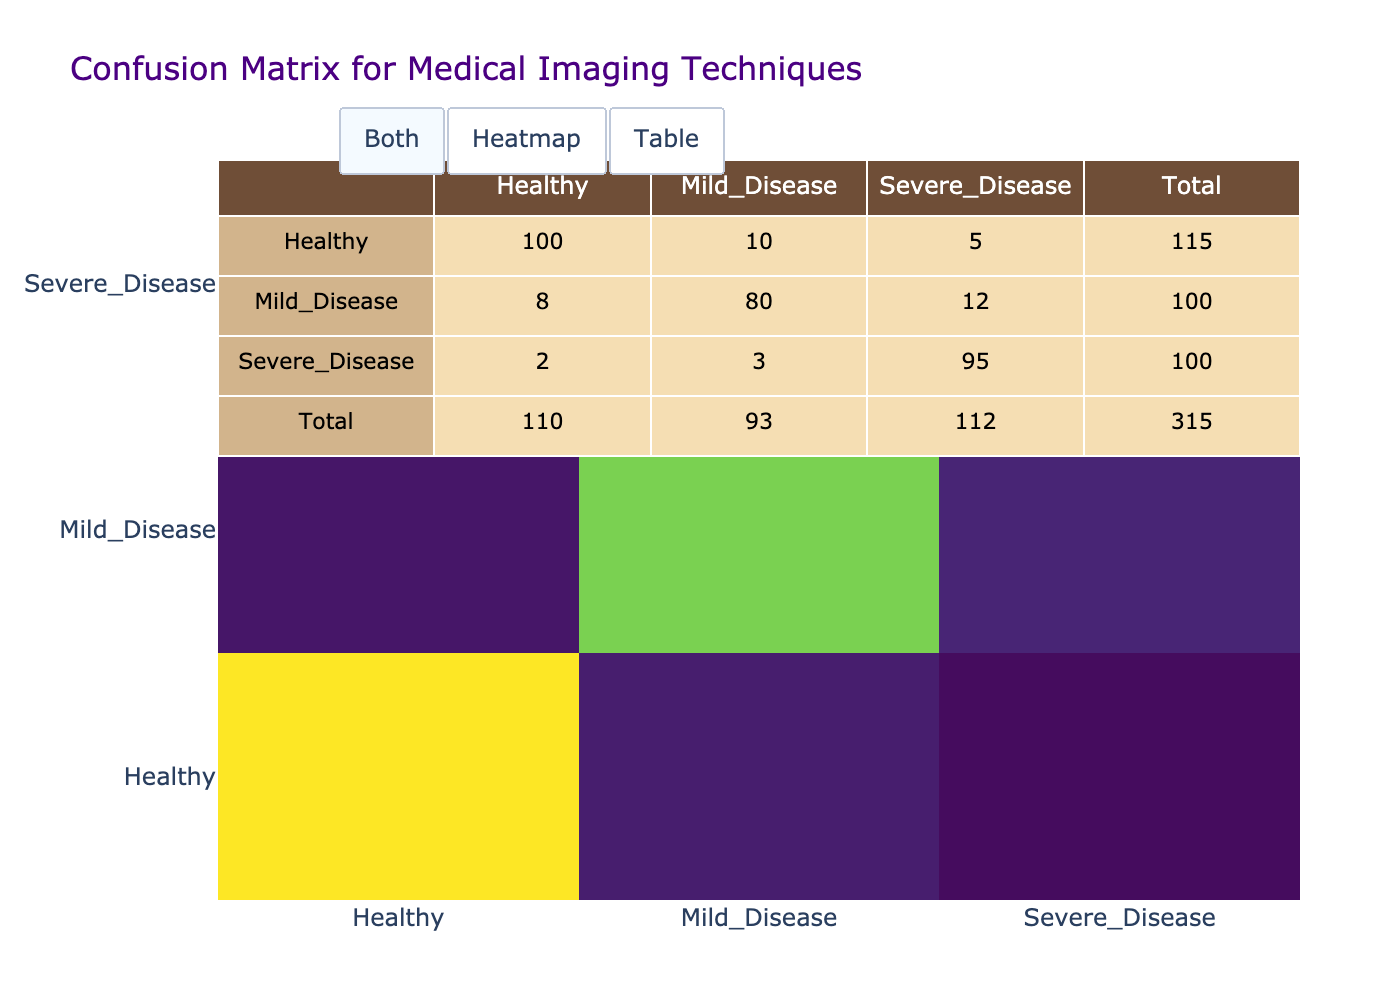What is the total number of Healthy predictions? To find the total number of Healthy predictions, I look at the column for Predicted_Label and sum the values for rows where the Predicted_Label is Healthy. These values are 100 (True_Label Healthy) + 8 (True_Label Mild_Disease) + 2 (True_Label Severe_Disease) = 110.
Answer: 110 What is the number of Severe_Disease cases misclassified as Healthy? In the confusion matrix, I refer to the row for True_Label Severe_Disease and look at the column for Predicted_Label Healthy. The value in that cell is 2, which indicates that 2 cases of Severe_Disease were incorrectly classified as Healthy.
Answer: 2 What percentage of Mild_Disease cases were correctly classified? To calculate this percentage, I check the row for True_Label Mild_Disease. The correctly classified count is the value in the cell for Mild_Disease predicted as Mild_Disease, which is 80. The total count for Mild_Disease is the sum of all values in that row: 80 (correct) + 8 (incorrectly classified as Healthy) + 12 (incorrectly classified as Severe_Disease) = 100. The percentage is (80/100)*100 = 80%.
Answer: 80% Is there any instance of Healthy cases being classified as Severe_Disease? I examine the confusion matrix for the row corresponding to True_Label Healthy and the column for Predicted_Label Severe_Disease. The value in that cell is 5, confirming that there are instances of Healthy cases misclassified as Severe_Disease.
Answer: Yes What is the total number of Severe_Disease cases? For this, I look at the row for True_Label Severe_Disease. To get the total, I sum all the values in that row: 2 (misclassified as Healthy) + 3 (misclassified as Mild_Disease) + 95 (correctly classified as Severe_Disease) = 100.
Answer: 100 What is the average number of misclassified cases across all categories? First, I identify the total misclassified cases by summing the off-diagonal elements of all rows: 10 (Healthy as Mild_Disease) + 5 (Healthy as Severe_Disease) + 8 (Mild_Disease as Healthy) + 12 (Mild_Disease as Severe_Disease) + 2 (Severe_Disease as Healthy) + 3 (Severe_Disease as Mild_Disease) = 40. Then, I divide this by the number of categories (3 categories) to find the average: 40/3 ≈ 13.33.
Answer: 13.33 What is the ratio of Healthy cases correctly classified to Mild_Disease cases correctly classified? From the confusion matrix, Healthy correctly classified cases are 100, while Mild_Disease correctly classified cases are 80. Therefore, the ratio is 100:80, which simplifies to 5:4.
Answer: 5:4 How many cases of Severe_Disease were misclassified as Mild_Disease? In the confusion matrix, I refer to the row for True_Label Severe_Disease and check the column for Predicted_Label Mild_Disease. The value in that cell is 3, indicating that 3 cases of Severe_Disease were incorrectly classified as Mild_Disease.
Answer: 3 What is the total count of predictions made for Mild_Disease? I look at the row for True_Label Mild_Disease and sum all counts: 8 (misclassified as Healthy) + 80 (correctly classified as Mild_Disease) + 12 (misclassified as Severe_Disease) = 100.
Answer: 100 